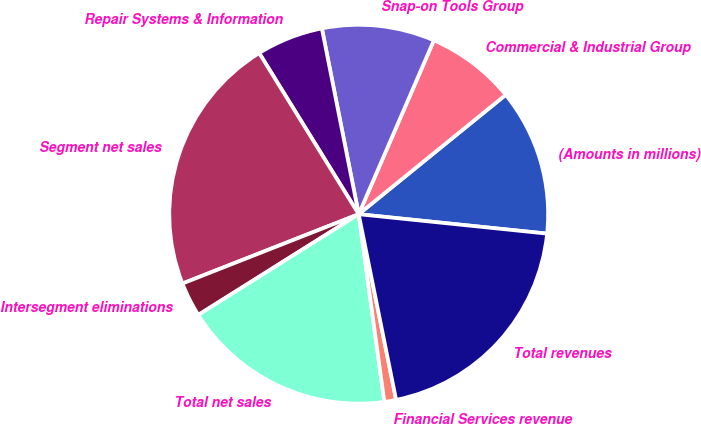<chart> <loc_0><loc_0><loc_500><loc_500><pie_chart><fcel>(Amounts in millions)<fcel>Commercial & Industrial Group<fcel>Snap-on Tools Group<fcel>Repair Systems & Information<fcel>Segment net sales<fcel>Intersegment eliminations<fcel>Total net sales<fcel>Financial Services revenue<fcel>Total revenues<nl><fcel>12.49%<fcel>7.65%<fcel>9.61%<fcel>5.69%<fcel>22.16%<fcel>2.96%<fcel>18.24%<fcel>1.0%<fcel>20.2%<nl></chart> 